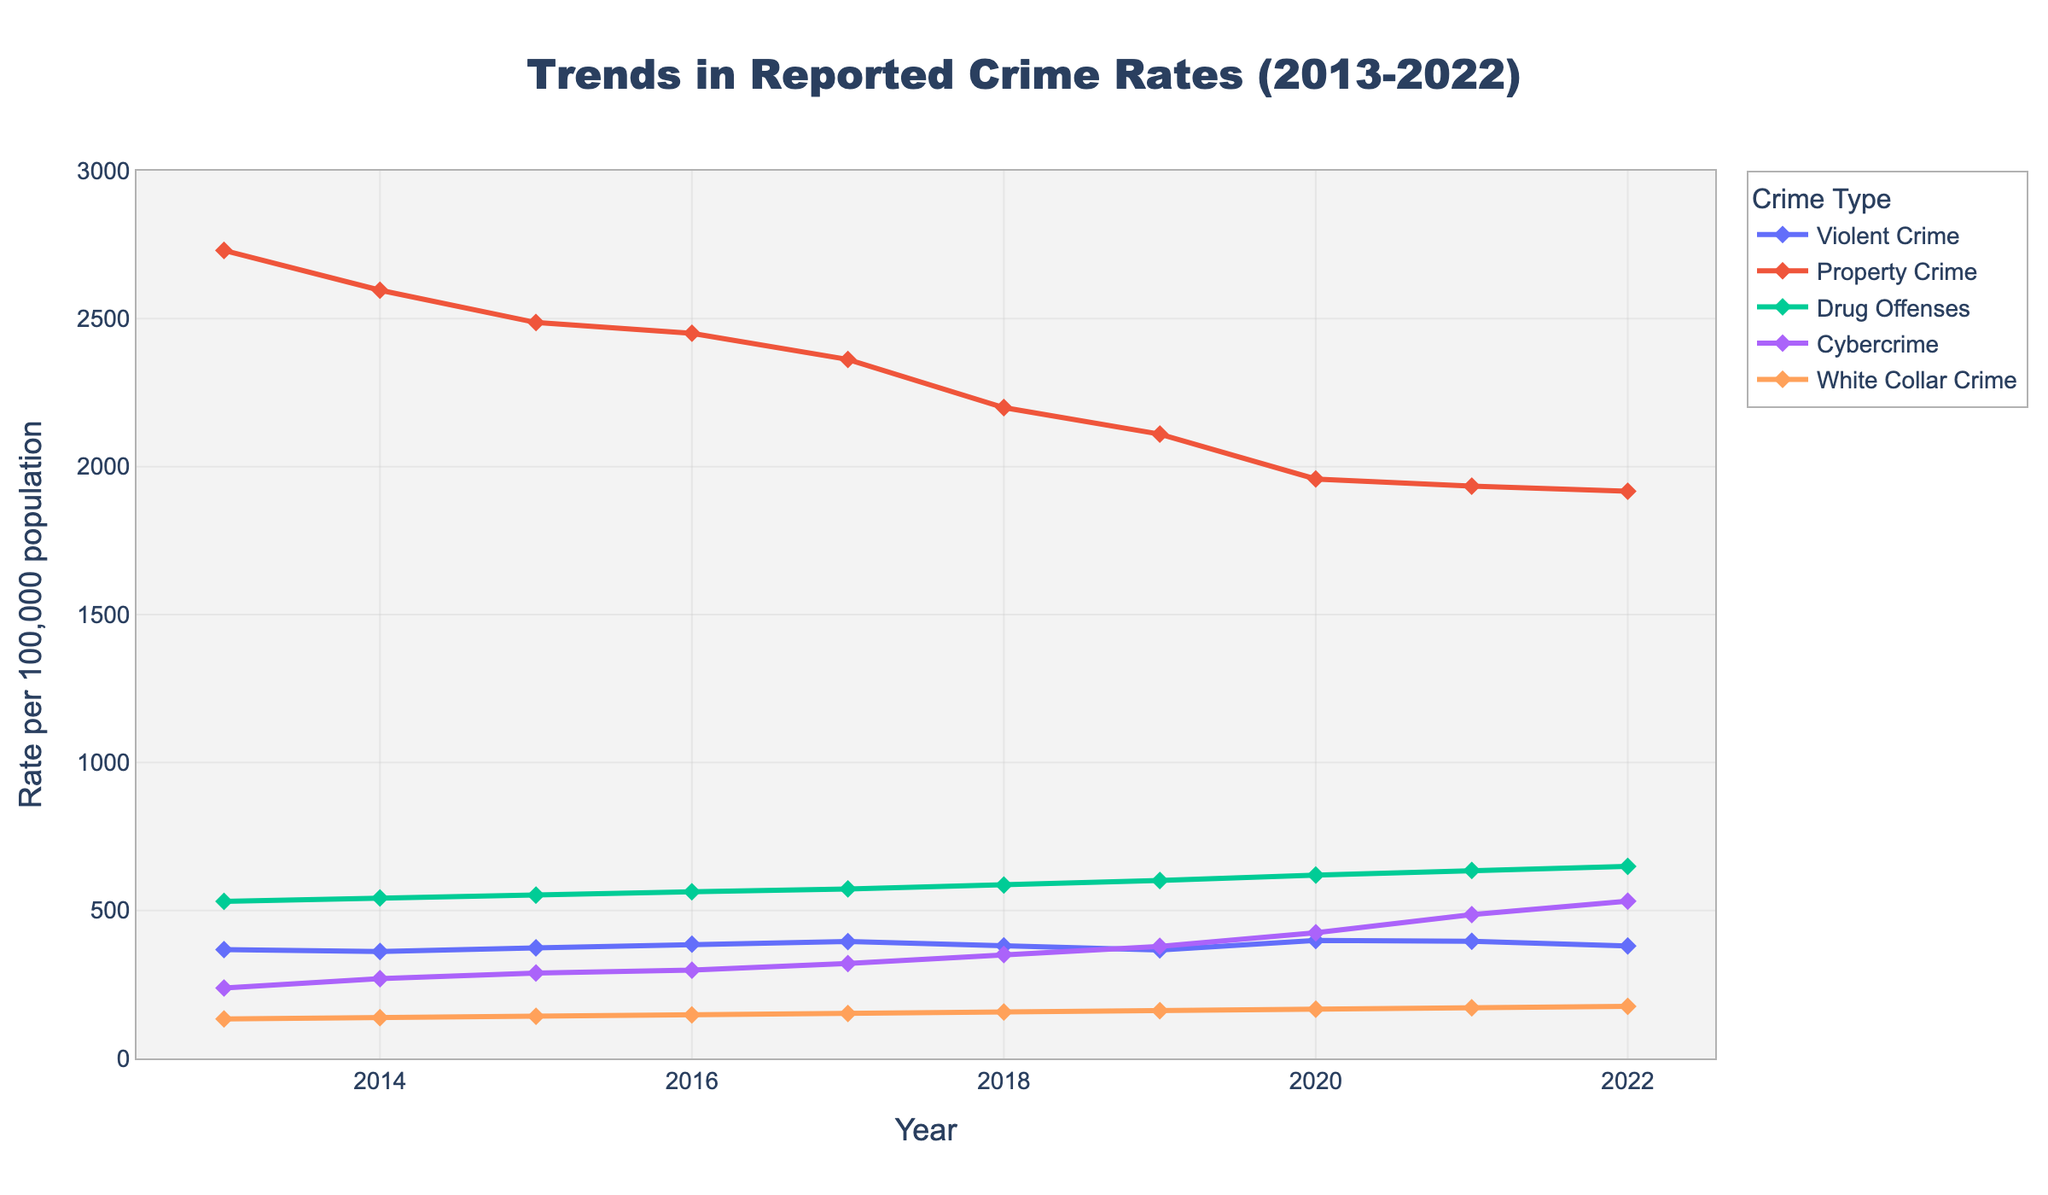What is the overall trend of violent crime rates from 2013 to 2022? The data shows that violent crime rates fluctuate over the decade, starting at 367.9 per 100,000 population in 2013, peaking in 2020 at 398.5, and ending at 380.1 in 2022. Visually, the line for violent crime rates trends upward overall.
Answer: Increasing Comparing 2013 and 2022, did the reported rates of property crime increase, decrease, or remain the same? In 2013, property crime rates were at 2730.7 per 100,000 population, while in 2022, they were at 1916.7 per 100,000 population. The line graph shows a downward trend for property crime rates throughout the decade.
Answer: Decrease Which type of crime saw the most significant increase in rate per 100,000 population from 2013 to 2022? By observing the line chart, cybercrime shows the most significant increase, starting at 238.1 in 2013 and rising to 531.7 in 2022. This significant rise indicates the highest growth among all types of crimes depicted.
Answer: Cybercrime Between which two years did the rate of drug offenses increase the most? By comparing the slopes of the lines for drug offenses, the steepest increase occurs between 2017 (572.8 per 100,000 population) and 2018 (586.1 per 100,000 population). This change indicates that the rate increased the most between these two years.
Answer: 2017 and 2018 What is the average rate of white-collar crime over the decade? To calculate the average, sum the rates of white-collar crime for each year and divide by the number of years: (133.2 + 137.8 + 142.5 + 147.1 + 151.9 + 156.7 + 161.5 + 166.3 + 171.2 + 176.0) / 10 = 154.42 per 100,000 population.
Answer: 154.42 How does the rate of cybercrime in 2022 compare to that in 2014? The rate of cybercrime in 2022 is 531.7 per 100,000 population, whereas in 2014, it was 269.4. The graph shows a dramatic rise in cybercrime rates, much higher in 2022 than in 2014.
Answer: Much Higher Which crime type experienced the least variation in its rate over the decade? By observing the fluctuation in the lines, white-collar crime shows the least variation. Its rates gradually increase, without many steep rises or drops over the years from 133.2 in 2013 to 176.0 in 2022.
Answer: White-collar crime What is the difference in property crime rates between the highest and lowest years? The highest property crime rate is in 2013 at 2730.7 per 100,000 population, and the lowest is in 2022 at 1916.7. The difference is 2730.7 - 1916.7 = 814.
Answer: 814 If you average the rates of all crime types in 2022, what is the value? Sum the rates of all crime types in 2022 and divide by 5: (380.1 + 1916.7 + 648.9 + 531.7 + 176.0) / 5 = 730.68 per 100,000 population.
Answer: 730.68 